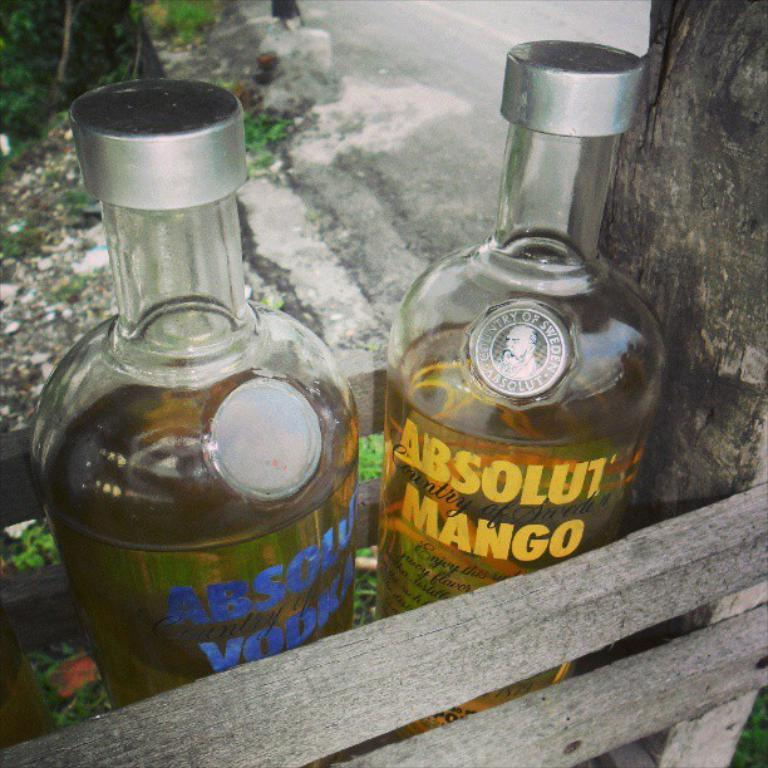Provide a one-sentence caption for the provided image. One of the two Absolut Vodka bottles in a wooden crate is flavored with mango. 